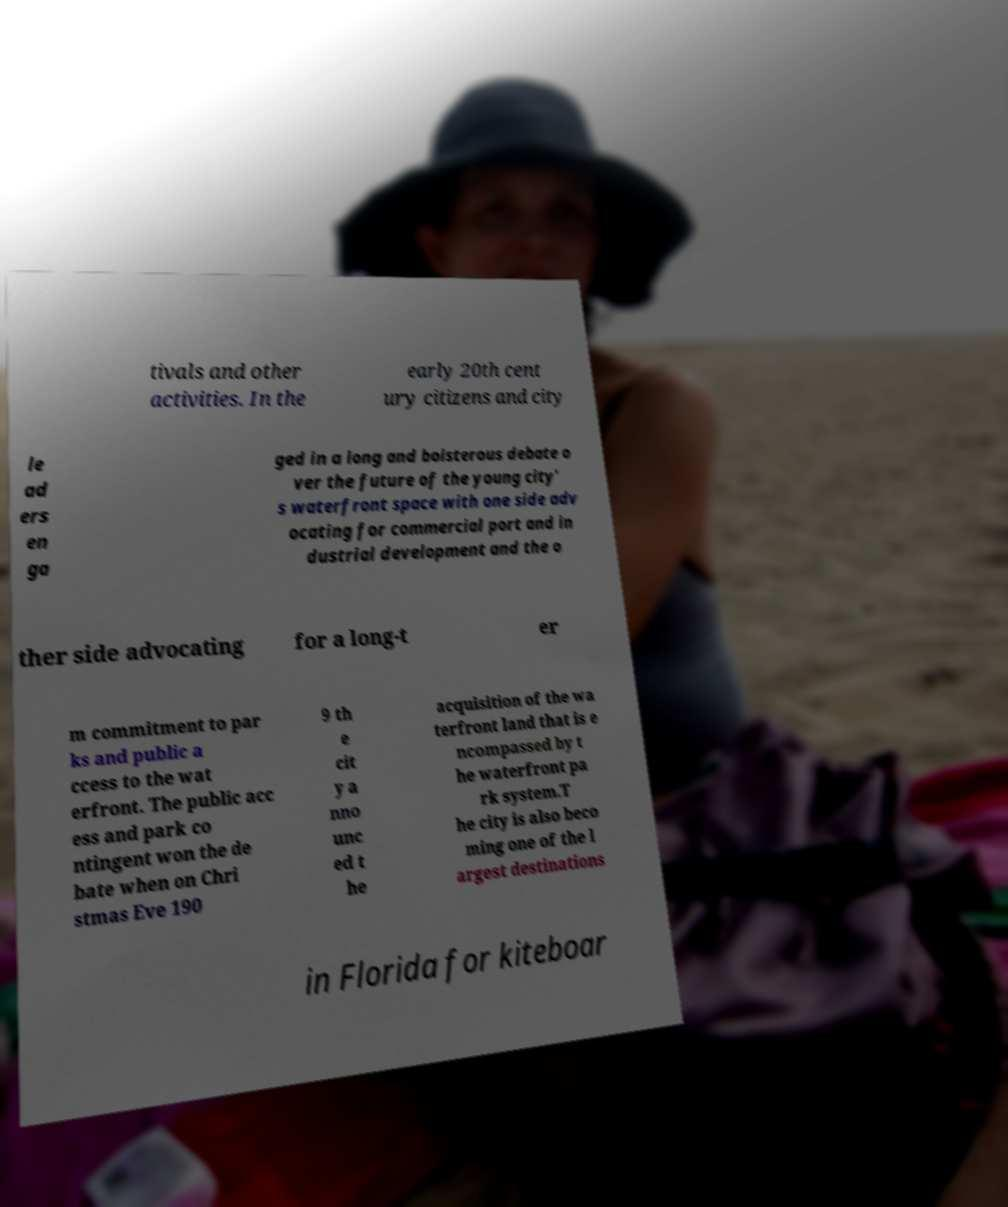Please read and relay the text visible in this image. What does it say? tivals and other activities. In the early 20th cent ury citizens and city le ad ers en ga ged in a long and boisterous debate o ver the future of the young city' s waterfront space with one side adv ocating for commercial port and in dustrial development and the o ther side advocating for a long-t er m commitment to par ks and public a ccess to the wat erfront. The public acc ess and park co ntingent won the de bate when on Chri stmas Eve 190 9 th e cit y a nno unc ed t he acquisition of the wa terfront land that is e ncompassed by t he waterfront pa rk system.T he city is also beco ming one of the l argest destinations in Florida for kiteboar 